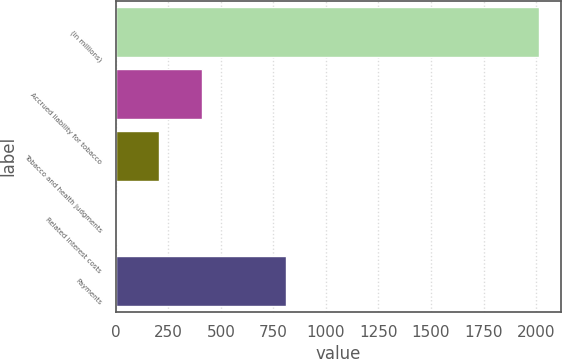Convert chart. <chart><loc_0><loc_0><loc_500><loc_500><bar_chart><fcel>(in millions)<fcel>Accrued liability for tobacco<fcel>Tobacco and health judgments<fcel>Related interest costs<fcel>Payments<nl><fcel>2016<fcel>408.8<fcel>207.9<fcel>7<fcel>810.6<nl></chart> 